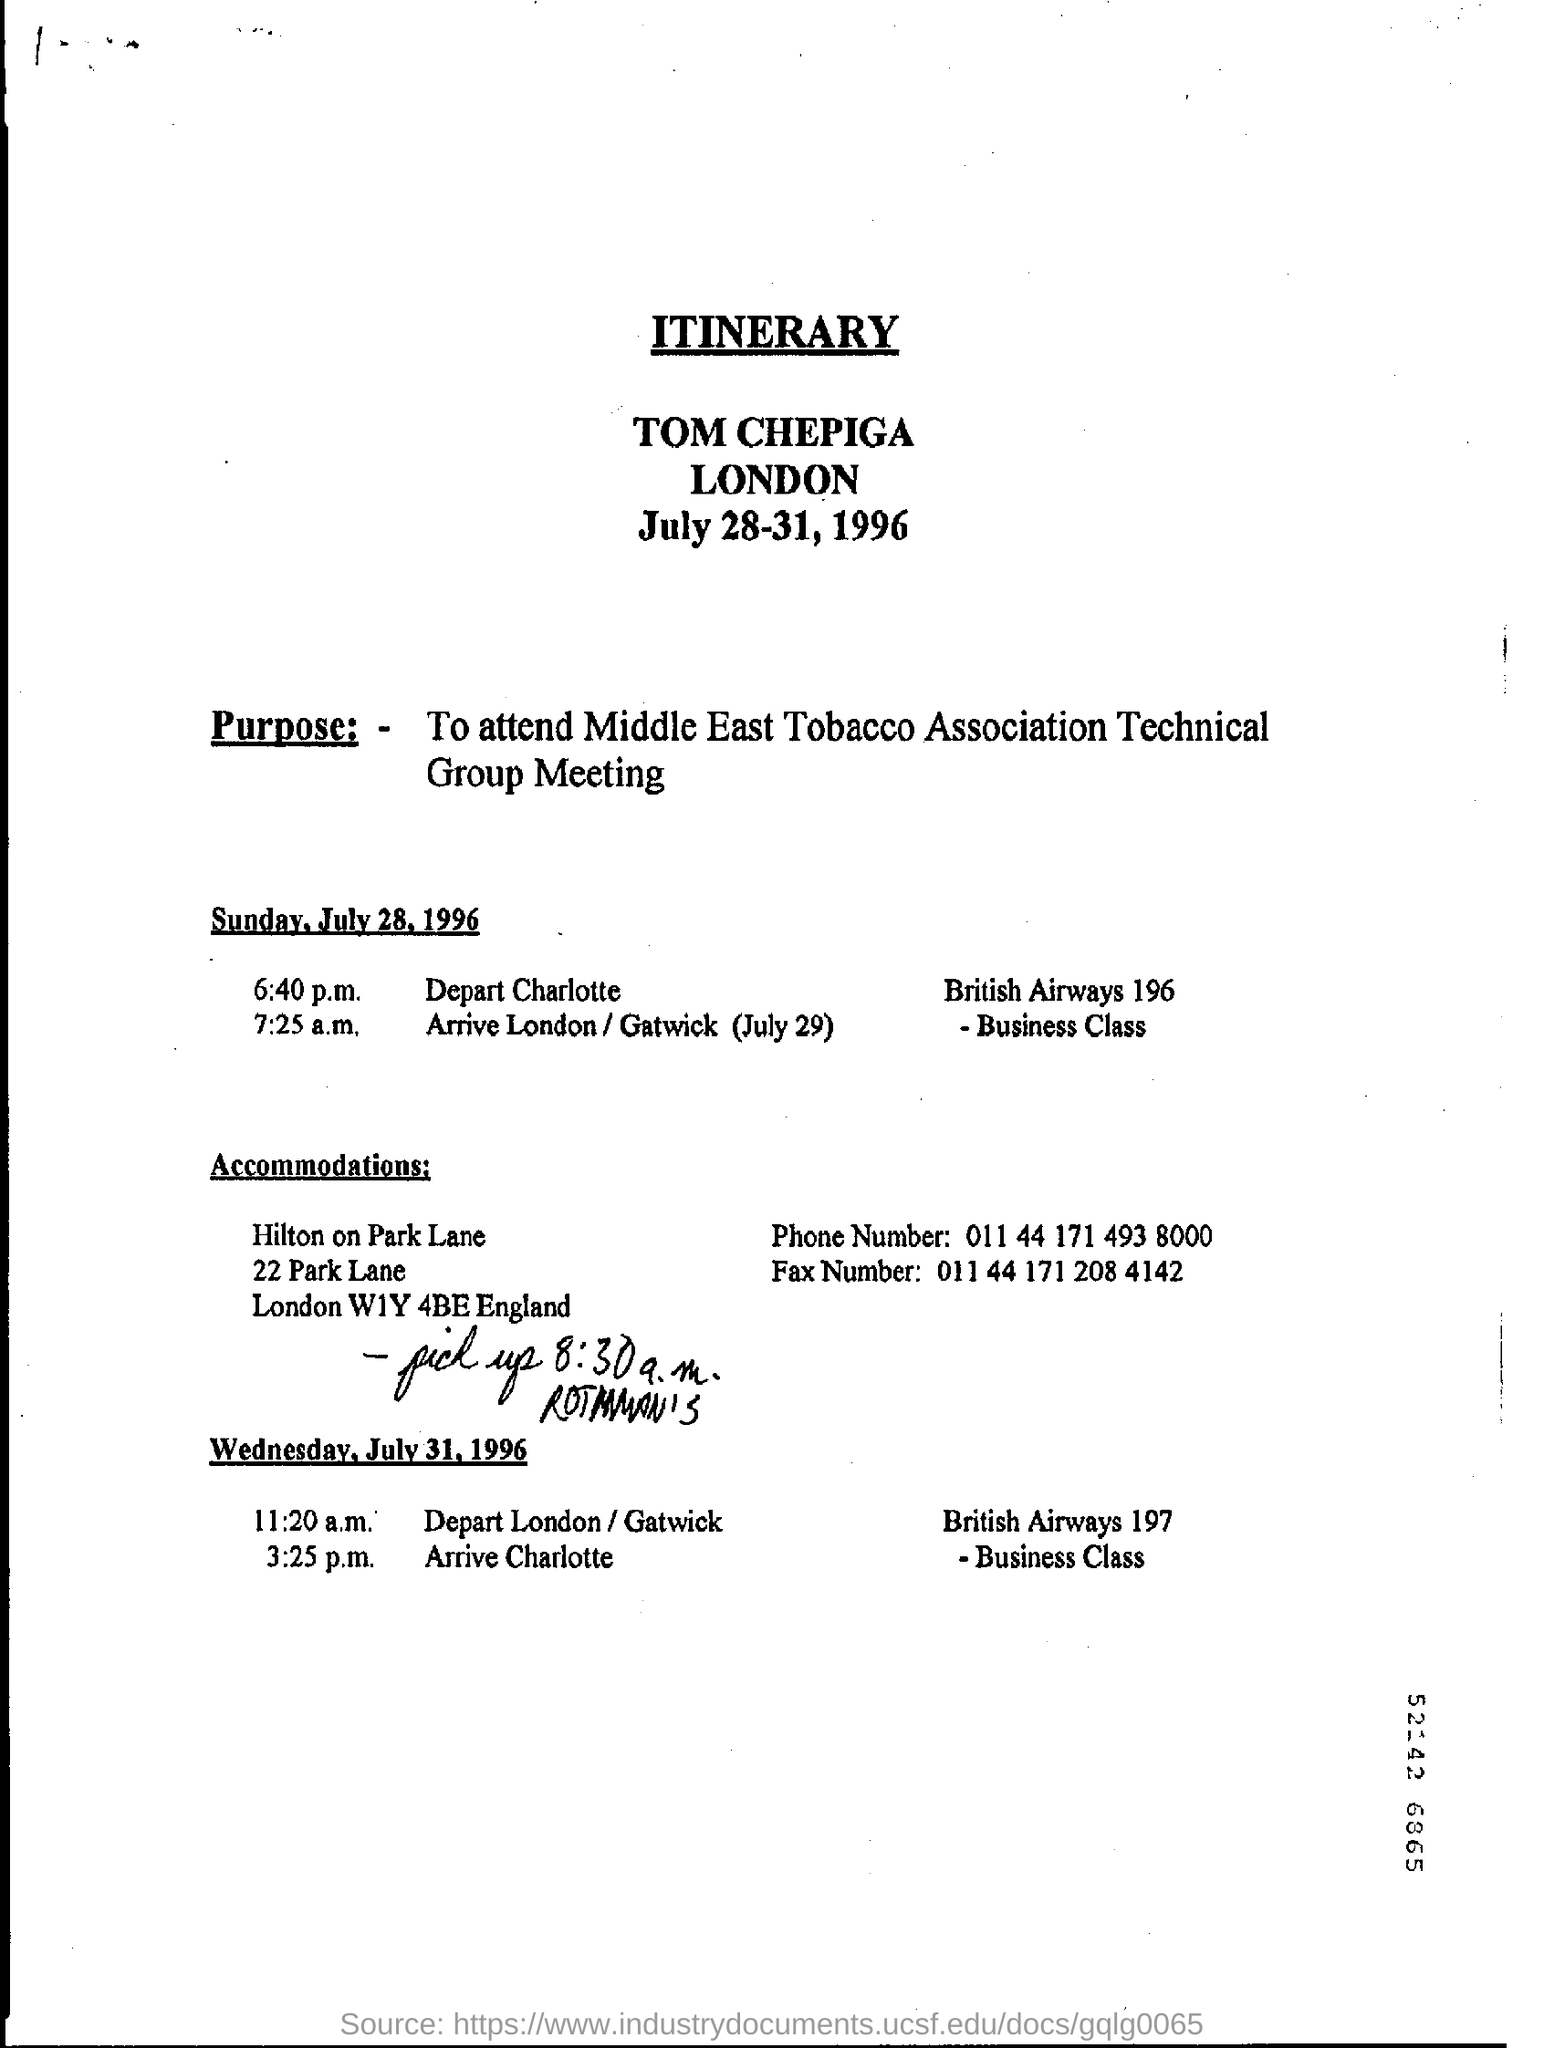Point out several critical features in this image. The purpose is to attend the Middle East Tobacco Association Technical Group Meeting. 